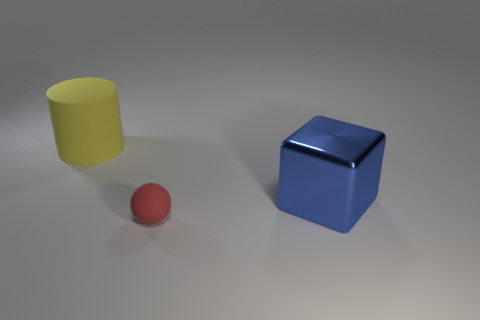What number of other balls are the same size as the matte sphere?
Provide a short and direct response. 0. Do the rubber thing right of the large yellow cylinder and the thing that is left of the small red rubber thing have the same size?
Ensure brevity in your answer.  No. How many objects are either red rubber things or objects that are in front of the blue metallic block?
Your answer should be compact. 1. What color is the small rubber thing?
Provide a short and direct response. Red. There is a large object that is left of the matte object in front of the big thing that is to the right of the big yellow rubber cylinder; what is its material?
Ensure brevity in your answer.  Rubber. There is a yellow object that is the same material as the tiny red thing; what is its size?
Provide a succinct answer. Large. Does the yellow matte object have the same size as the rubber object in front of the big yellow cylinder?
Your answer should be very brief. No. How many big cubes are in front of the tiny ball that is in front of the large thing that is right of the large yellow thing?
Keep it short and to the point. 0. There is a red thing; are there any big blue cubes on the right side of it?
Your answer should be very brief. Yes. What is the shape of the tiny red matte object?
Ensure brevity in your answer.  Sphere. 